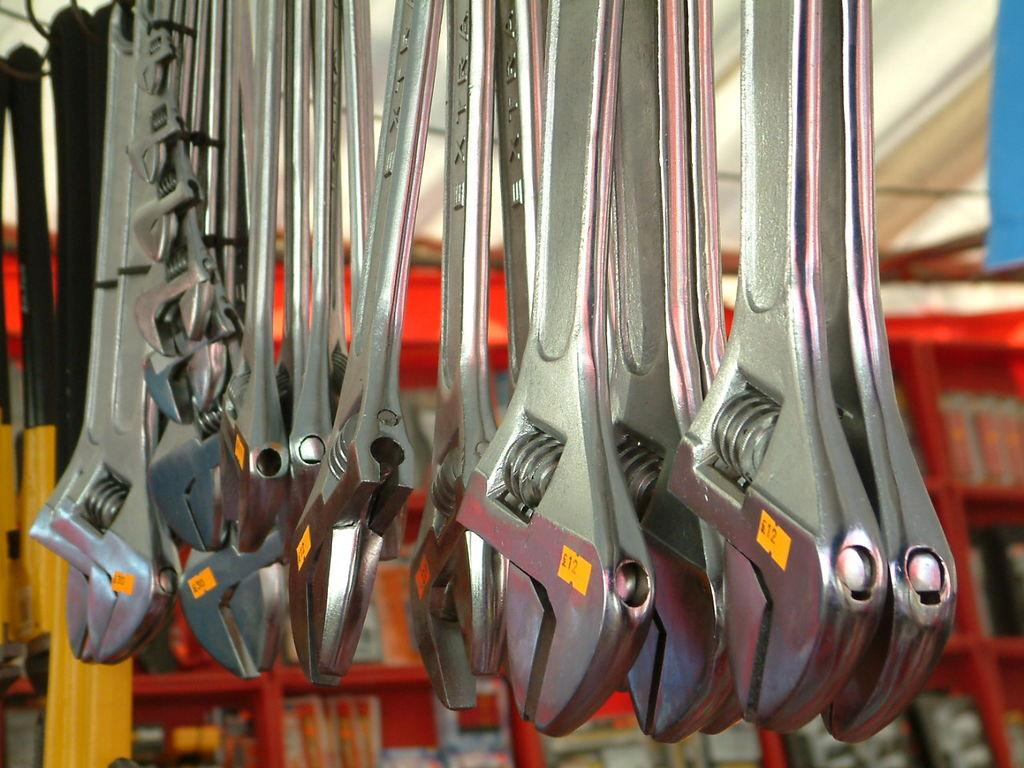What tools are visible in the image? There is a set of wrenches in the image. What color is the rag in the background of the image? The background of the image contains a red color rag. What type of disgust can be seen on the wrenches in the image? There is no indication of disgust on the wrenches in the image; they are simply tools. 